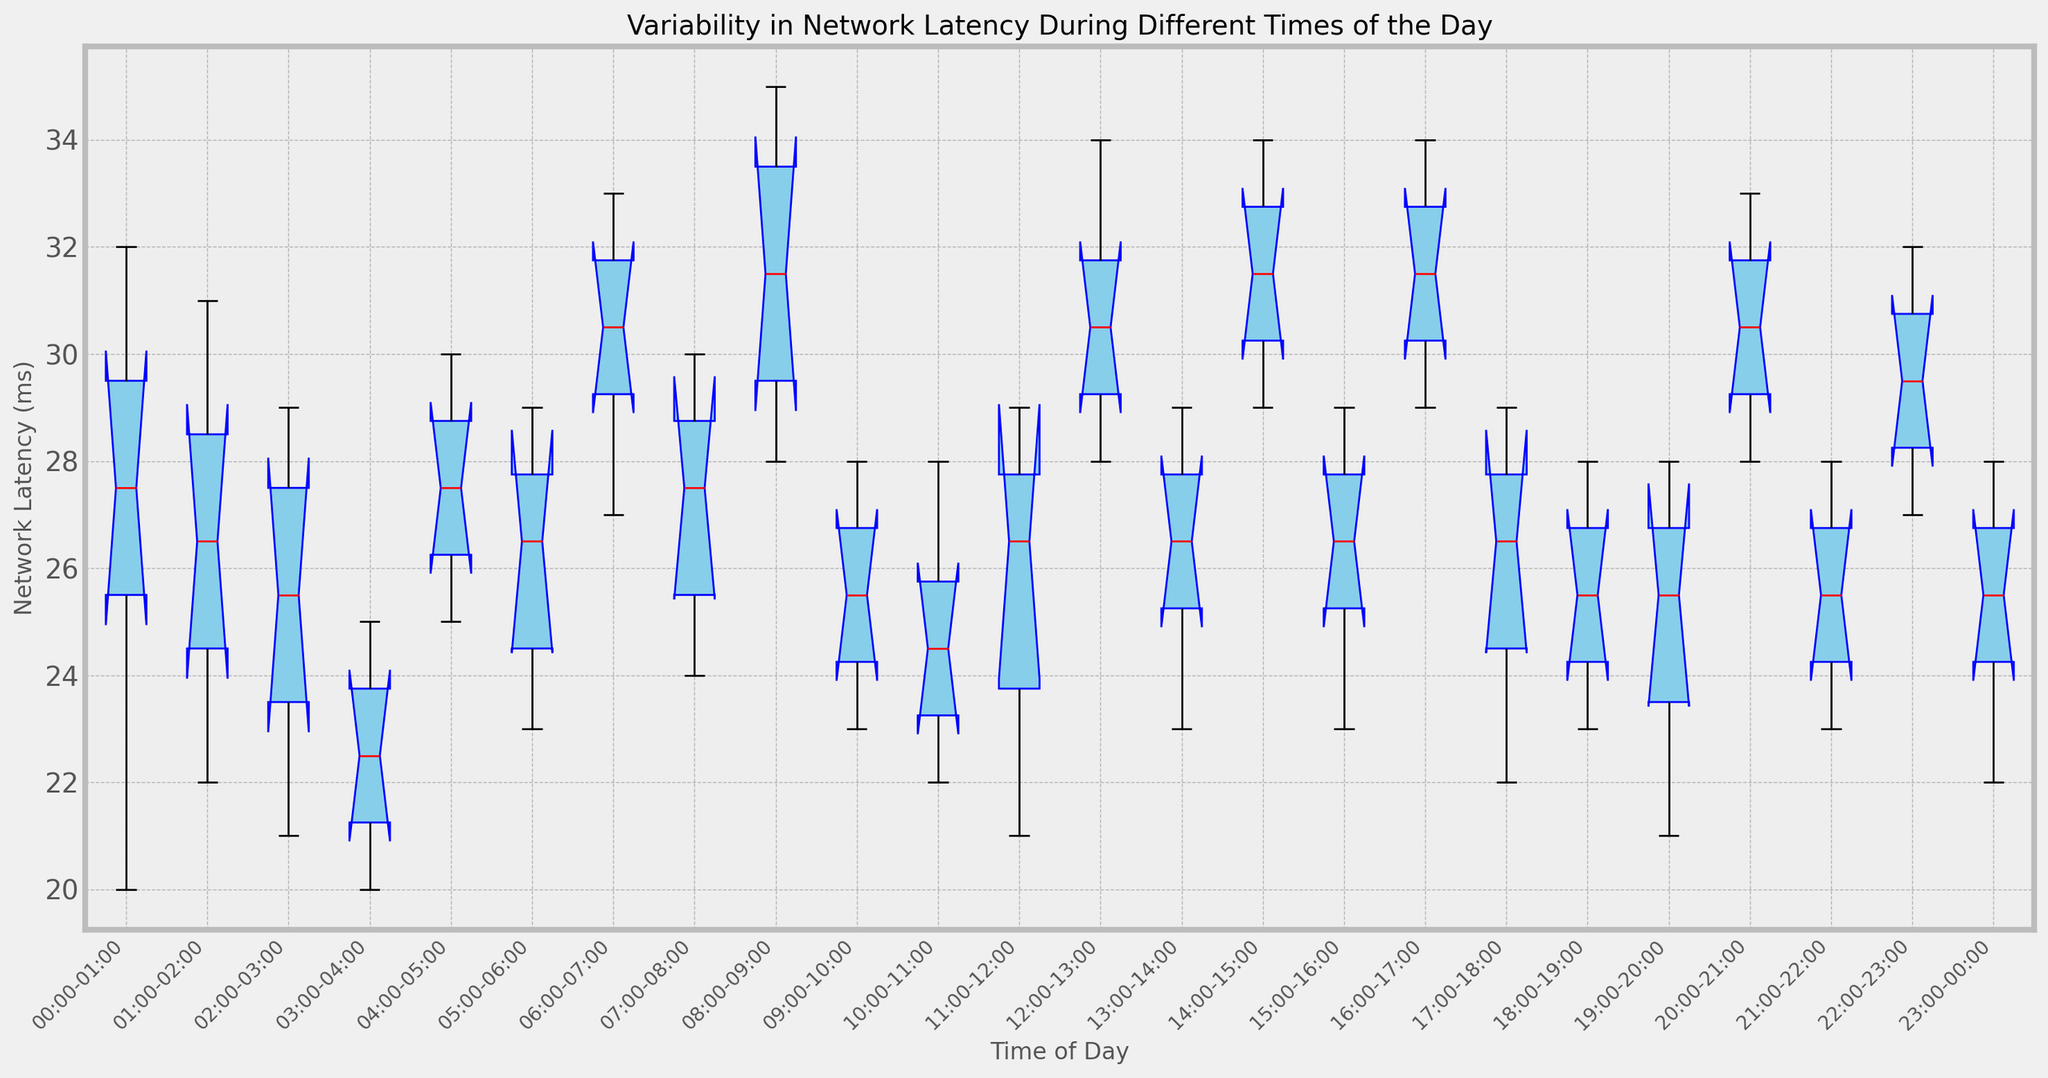Which time of the day has the highest median network latency? Look at the red lines inside the boxes for each time period to identify the median values. Note that 08:00-09:00 shows a higher median compared to other periods.
Answer: 08:00-09:00 Which time of the day has the lowest median network latency? Identify the lowest red line among all time periods. The box plot for 03:00-04:00 exhibits the lowest median line.
Answer: 03:00-04:00 During which time period is the variability in network latency the greatest? Check the length of the whiskers and the range of the boxes. The greatest distance between the whiskers indicates the highest variability, noticeable in 08:00-09:00.
Answer: 08:00-09:00 Which period has the smallest interquartile range (IQR)? Observe the height of each box. The smallest IQR is observed when the box height is the smallest, which occurs at 19:00-20:00.
Answer: 19:00-20:00 Between 00:00-01:00 and 23:00-00:00, which time period has a higher maximum latency? Find the top whisker or the outliers to determine the maximum value. 00:00-01:00 shows a higher maximum latency compared to 23:00-00:00.
Answer: 00:00-01:00 Which boxplot shows an outlier, and what is the outlier value? Identify the red dots outside the whiskers. 07:00-08:00 has an outlier indicated by a red dot around 30 ms
Answer: 07:00-08:00, 30 ms Is the network latency more variable in the early hours (00:00-06:00) or late hours (18:00-00:00)? Compare the spread and range of the boxes and whiskers in the specified time ranges. Early hours (00:00-06:00) show more consistent variability compared to late hours (18:00-00:00) where there is higher variability.
Answer: Late hours (18:00-00:00) What is the median latency difference between 04:00-05:00 and 08:00-09:00? Determine the median values (red lines) for each time period and calculate the difference. The median latency for 04:00-05:00 is approximately 28 ms, and for 08:00-09:00, it is around 31 ms. The difference is 31 - 28 = 3.
Answer: 3 ms Which time periods have a skewed distribution based on the box plot shape? Identify time periods where the box is not symmetric, considering longer whiskers or outlying points. 11:00-12:00 and 13:00-14:00 are noticeably skewed, indicating potential skewed distribution.
Answer: 11:00-12:00, 13:00-14:00 